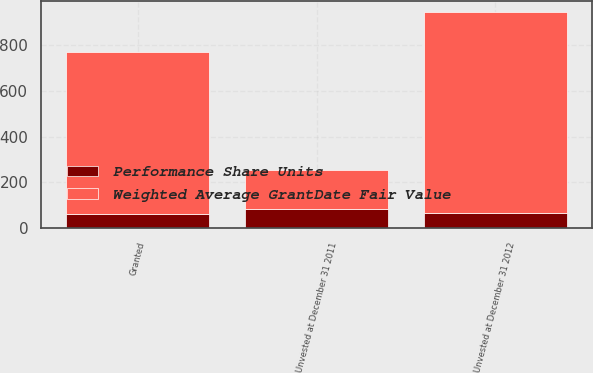Convert chart to OTSL. <chart><loc_0><loc_0><loc_500><loc_500><stacked_bar_chart><ecel><fcel>Unvested at December 31 2011<fcel>Granted<fcel>Unvested at December 31 2012<nl><fcel>Weighted Average GrantDate Fair Value<fcel>171<fcel>707<fcel>878<nl><fcel>Performance Share Units<fcel>81.7<fcel>63.37<fcel>66.93<nl></chart> 